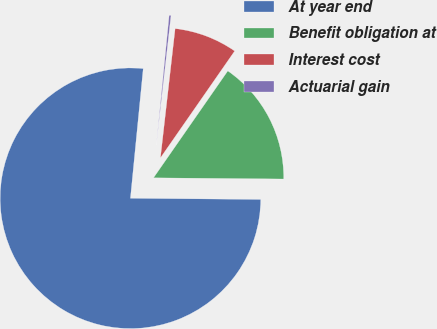Convert chart. <chart><loc_0><loc_0><loc_500><loc_500><pie_chart><fcel>At year end<fcel>Benefit obligation at<fcel>Interest cost<fcel>Actuarial gain<nl><fcel>76.43%<fcel>15.48%<fcel>7.86%<fcel>0.24%<nl></chart> 